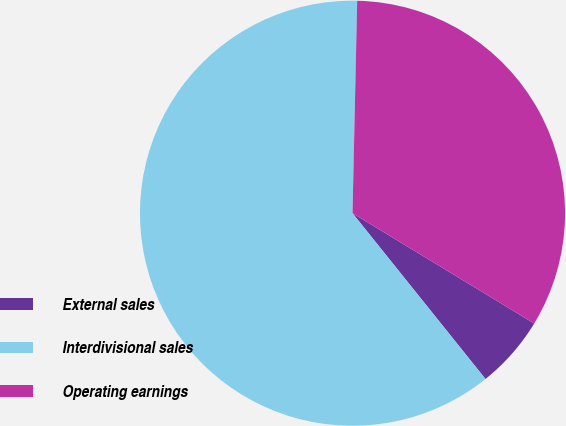Convert chart to OTSL. <chart><loc_0><loc_0><loc_500><loc_500><pie_chart><fcel>External sales<fcel>Interdivisional sales<fcel>Operating earnings<nl><fcel>5.56%<fcel>61.11%<fcel>33.33%<nl></chart> 